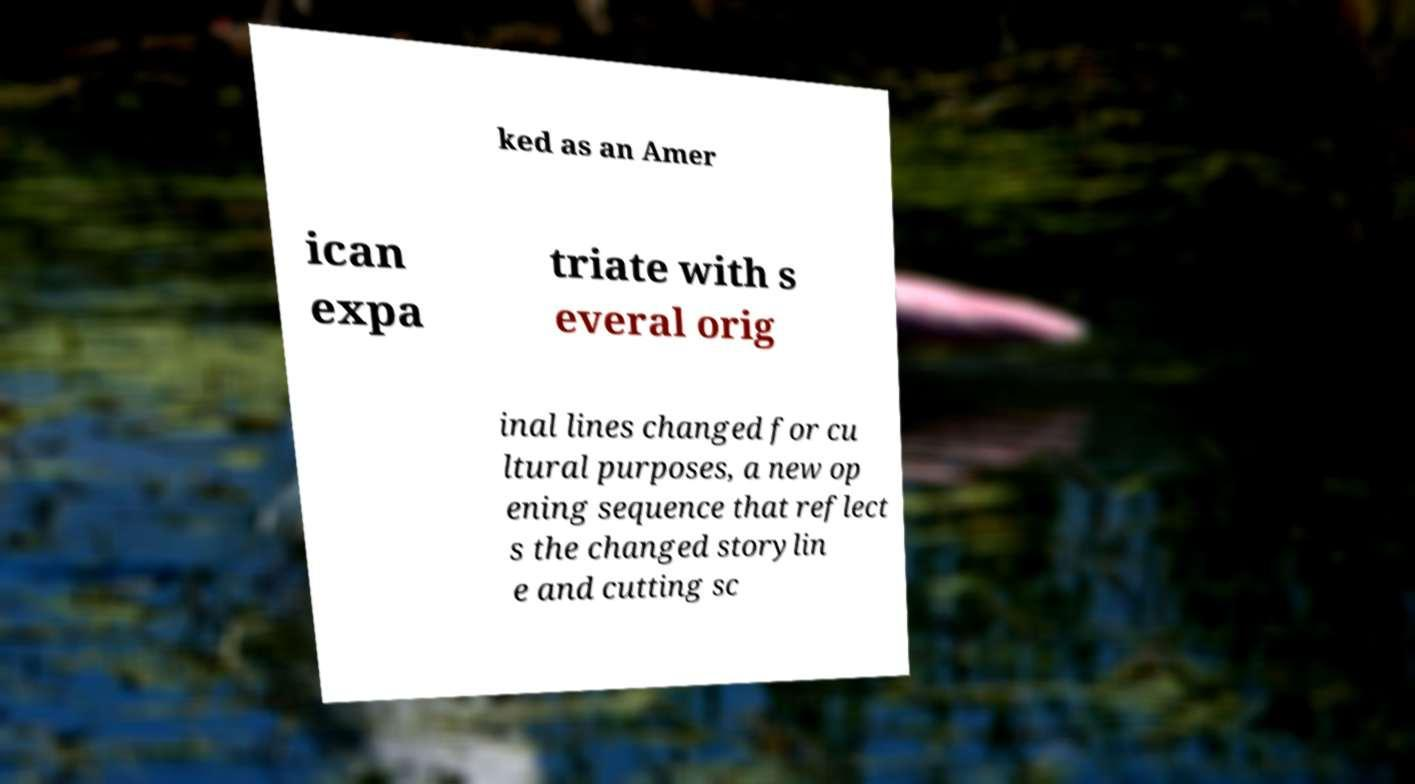Could you extract and type out the text from this image? ked as an Amer ican expa triate with s everal orig inal lines changed for cu ltural purposes, a new op ening sequence that reflect s the changed storylin e and cutting sc 